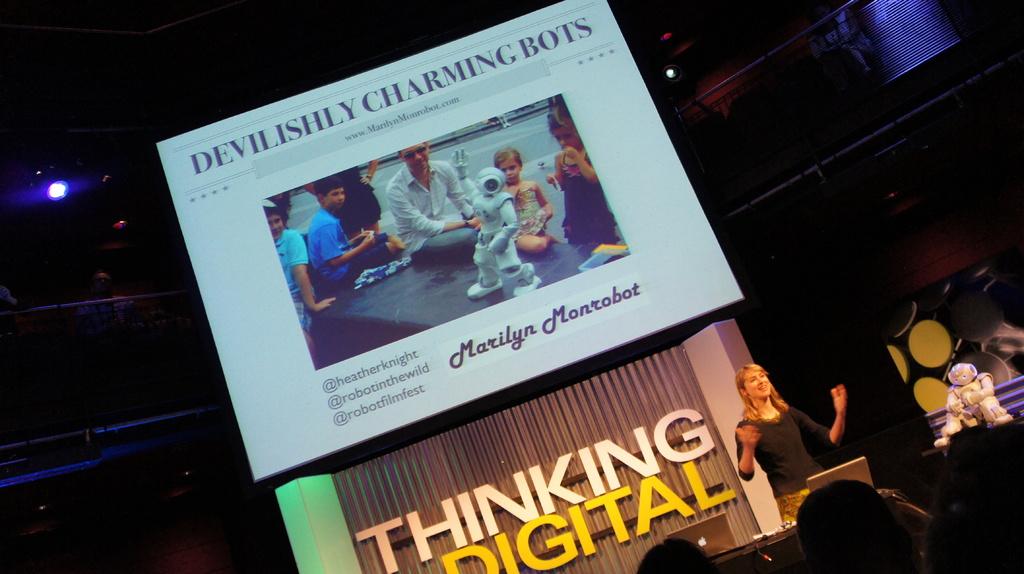What is the title of the article on the screen?
Ensure brevity in your answer.  Devilishly charming bots. What is the name of the robot on the projector?
Make the answer very short. Marilyn monrobot. 